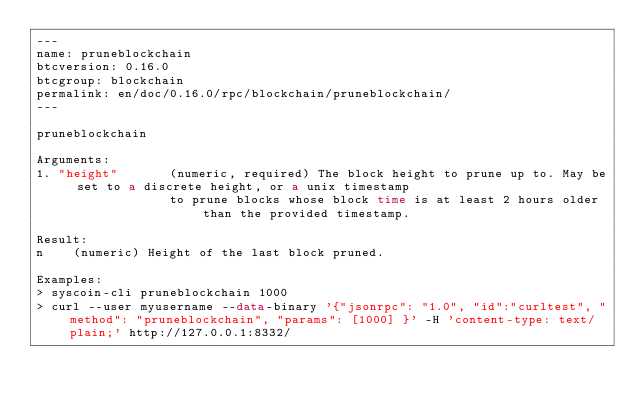Convert code to text. <code><loc_0><loc_0><loc_500><loc_500><_HTML_>---
name: pruneblockchain
btcversion: 0.16.0
btcgroup: blockchain
permalink: en/doc/0.16.0/rpc/blockchain/pruneblockchain/
---

pruneblockchain

Arguments:
1. "height"       (numeric, required) The block height to prune up to. May be set to a discrete height, or a unix timestamp
                  to prune blocks whose block time is at least 2 hours older than the provided timestamp.

Result:
n    (numeric) Height of the last block pruned.

Examples:
> syscoin-cli pruneblockchain 1000
> curl --user myusername --data-binary '{"jsonrpc": "1.0", "id":"curltest", "method": "pruneblockchain", "params": [1000] }' -H 'content-type: text/plain;' http://127.0.0.1:8332/


</code> 